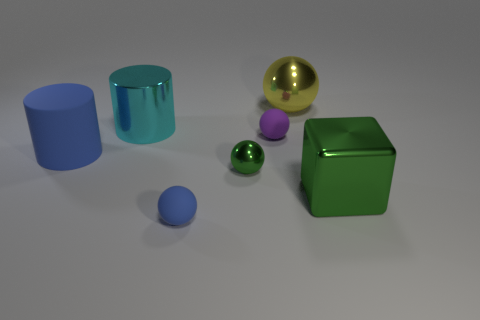The ball that is the same color as the big metal block is what size?
Your answer should be compact. Small. There is another matte thing that is the same shape as the tiny blue rubber object; what is its color?
Provide a succinct answer. Purple. Is there a large rubber cylinder that is on the right side of the green object right of the big yellow metallic thing?
Make the answer very short. No. There is a green thing that is right of the tiny purple matte sphere; is its shape the same as the purple rubber object?
Give a very brief answer. No. The purple thing has what shape?
Ensure brevity in your answer.  Sphere. How many big yellow balls have the same material as the large green thing?
Offer a terse response. 1. There is a shiny cube; does it have the same color as the sphere to the right of the small purple matte sphere?
Your answer should be compact. No. How many large yellow shiny blocks are there?
Your response must be concise. 0. Are there any small balls that have the same color as the large ball?
Offer a terse response. No. There is a large cylinder in front of the purple rubber ball that is on the right side of the big thing that is to the left of the large metallic cylinder; what color is it?
Ensure brevity in your answer.  Blue. 